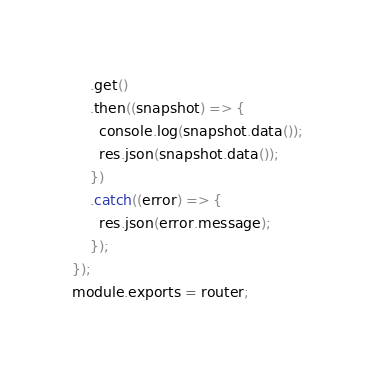Convert code to text. <code><loc_0><loc_0><loc_500><loc_500><_JavaScript_>    .get()
    .then((snapshot) => {
      console.log(snapshot.data());
      res.json(snapshot.data());
    })
    .catch((error) => {
      res.json(error.message);
    });
});
module.exports = router;
</code> 